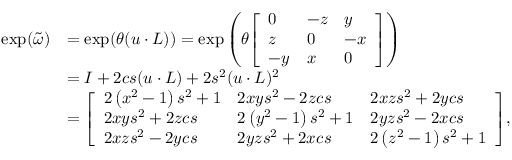<formula> <loc_0><loc_0><loc_500><loc_500>{ \begin{array} { r l } { \exp ( { \tilde { \omega } } ) } & { = \exp ( \theta ( { u \cdot L } ) ) = \exp \left ( \theta { \left [ \begin{array} { l l l } { 0 } & { - z } & { y } \\ { z } & { 0 } & { - x } \\ { - y } & { x } & { 0 } \end{array} \right ] } \right ) } \\ & { = { I } + 2 c s ( { u \cdot L } ) + 2 s ^ { 2 } ( { u \cdot L } ) ^ { 2 } } \\ & { = { \left [ \begin{array} { l l l } { 2 \left ( x ^ { 2 } - 1 \right ) s ^ { 2 } + 1 } & { 2 x y s ^ { 2 } - 2 z c s } & { 2 x z s ^ { 2 } + 2 y c s } \\ { 2 x y s ^ { 2 } + 2 z c s } & { 2 \left ( y ^ { 2 } - 1 \right ) s ^ { 2 } + 1 } & { 2 y z s ^ { 2 } - 2 x c s } \\ { 2 x z s ^ { 2 } - 2 y c s } & { 2 y z s ^ { 2 } + 2 x c s } & { 2 \left ( z ^ { 2 } - 1 \right ) s ^ { 2 } + 1 } \end{array} \right ] } , } \end{array} }</formula> 